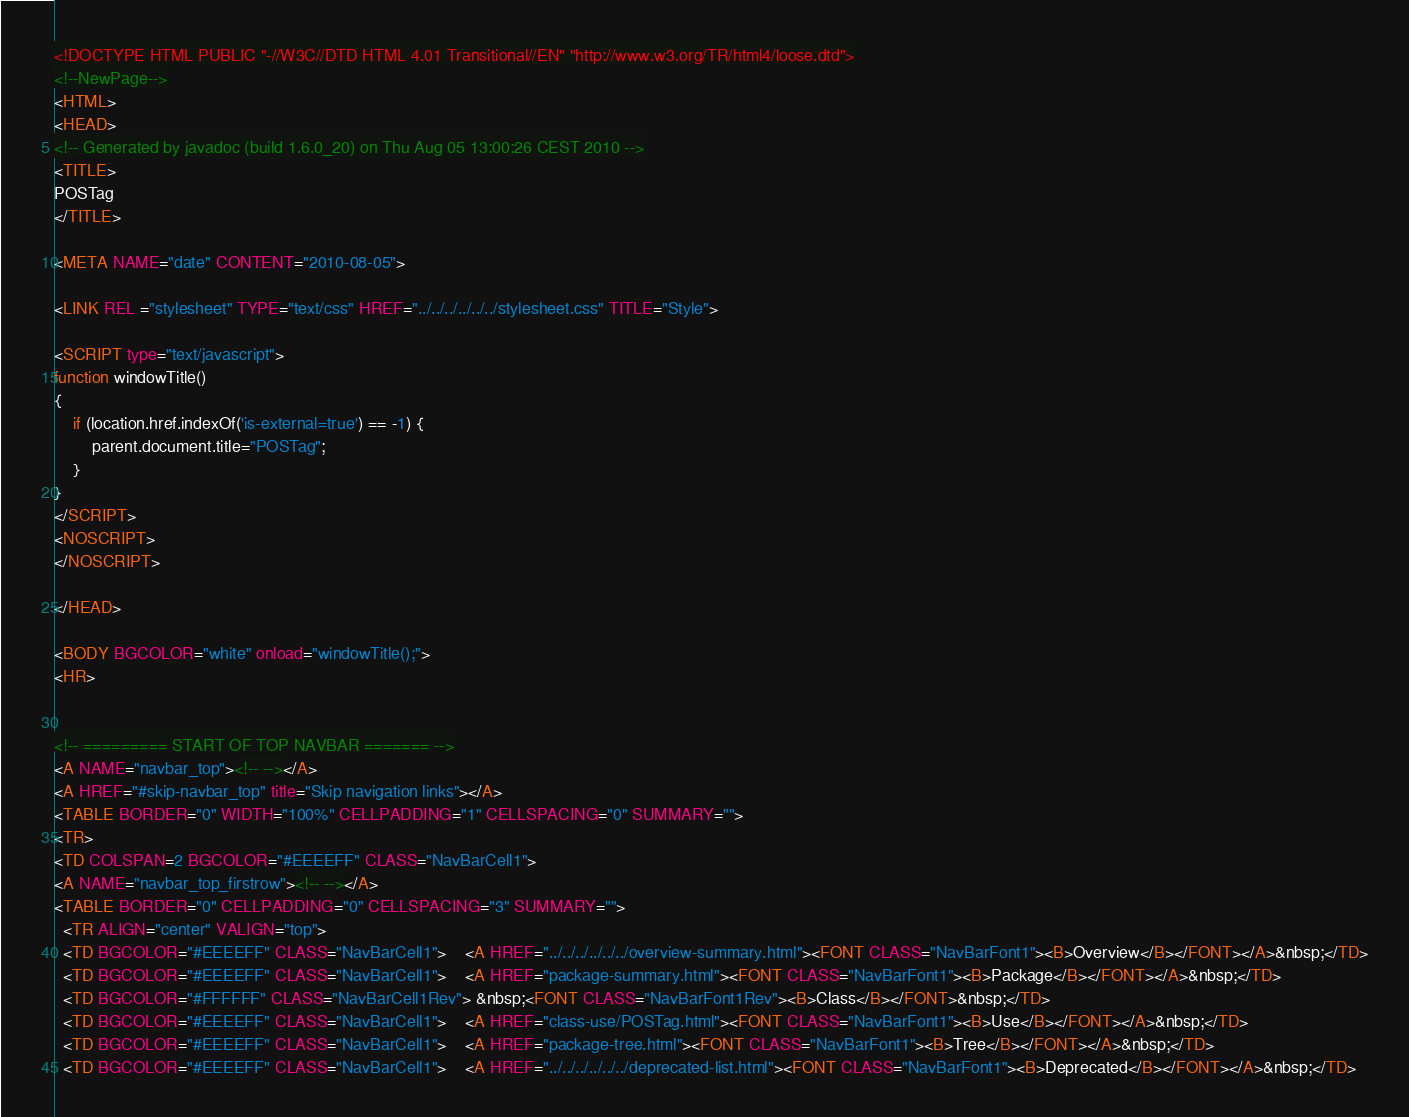Convert code to text. <code><loc_0><loc_0><loc_500><loc_500><_HTML_><!DOCTYPE HTML PUBLIC "-//W3C//DTD HTML 4.01 Transitional//EN" "http://www.w3.org/TR/html4/loose.dtd">
<!--NewPage-->
<HTML>
<HEAD>
<!-- Generated by javadoc (build 1.6.0_20) on Thu Aug 05 13:00:26 CEST 2010 -->
<TITLE>
POSTag
</TITLE>

<META NAME="date" CONTENT="2010-08-05">

<LINK REL ="stylesheet" TYPE="text/css" HREF="../../../../../../stylesheet.css" TITLE="Style">

<SCRIPT type="text/javascript">
function windowTitle()
{
    if (location.href.indexOf('is-external=true') == -1) {
        parent.document.title="POSTag";
    }
}
</SCRIPT>
<NOSCRIPT>
</NOSCRIPT>

</HEAD>

<BODY BGCOLOR="white" onload="windowTitle();">
<HR>


<!-- ========= START OF TOP NAVBAR ======= -->
<A NAME="navbar_top"><!-- --></A>
<A HREF="#skip-navbar_top" title="Skip navigation links"></A>
<TABLE BORDER="0" WIDTH="100%" CELLPADDING="1" CELLSPACING="0" SUMMARY="">
<TR>
<TD COLSPAN=2 BGCOLOR="#EEEEFF" CLASS="NavBarCell1">
<A NAME="navbar_top_firstrow"><!-- --></A>
<TABLE BORDER="0" CELLPADDING="0" CELLSPACING="3" SUMMARY="">
  <TR ALIGN="center" VALIGN="top">
  <TD BGCOLOR="#EEEEFF" CLASS="NavBarCell1">    <A HREF="../../../../../../overview-summary.html"><FONT CLASS="NavBarFont1"><B>Overview</B></FONT></A>&nbsp;</TD>
  <TD BGCOLOR="#EEEEFF" CLASS="NavBarCell1">    <A HREF="package-summary.html"><FONT CLASS="NavBarFont1"><B>Package</B></FONT></A>&nbsp;</TD>
  <TD BGCOLOR="#FFFFFF" CLASS="NavBarCell1Rev"> &nbsp;<FONT CLASS="NavBarFont1Rev"><B>Class</B></FONT>&nbsp;</TD>
  <TD BGCOLOR="#EEEEFF" CLASS="NavBarCell1">    <A HREF="class-use/POSTag.html"><FONT CLASS="NavBarFont1"><B>Use</B></FONT></A>&nbsp;</TD>
  <TD BGCOLOR="#EEEEFF" CLASS="NavBarCell1">    <A HREF="package-tree.html"><FONT CLASS="NavBarFont1"><B>Tree</B></FONT></A>&nbsp;</TD>
  <TD BGCOLOR="#EEEEFF" CLASS="NavBarCell1">    <A HREF="../../../../../../deprecated-list.html"><FONT CLASS="NavBarFont1"><B>Deprecated</B></FONT></A>&nbsp;</TD></code> 